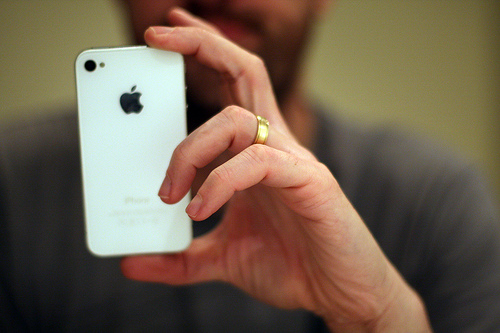<image>
Is there a ring next to the finger? No. The ring is not positioned next to the finger. They are located in different areas of the scene. Is there a iphone next to the man? No. The iphone is not positioned next to the man. They are located in different areas of the scene. Is the man behind the phone? Yes. From this viewpoint, the man is positioned behind the phone, with the phone partially or fully occluding the man. Is there a ring in front of the man? Yes. The ring is positioned in front of the man, appearing closer to the camera viewpoint. 